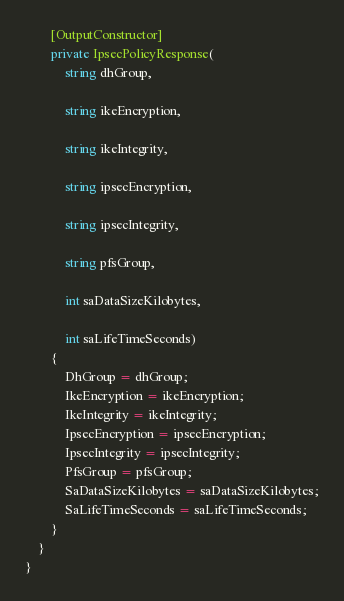Convert code to text. <code><loc_0><loc_0><loc_500><loc_500><_C#_>
        [OutputConstructor]
        private IpsecPolicyResponse(
            string dhGroup,

            string ikeEncryption,

            string ikeIntegrity,

            string ipsecEncryption,

            string ipsecIntegrity,

            string pfsGroup,

            int saDataSizeKilobytes,

            int saLifeTimeSeconds)
        {
            DhGroup = dhGroup;
            IkeEncryption = ikeEncryption;
            IkeIntegrity = ikeIntegrity;
            IpsecEncryption = ipsecEncryption;
            IpsecIntegrity = ipsecIntegrity;
            PfsGroup = pfsGroup;
            SaDataSizeKilobytes = saDataSizeKilobytes;
            SaLifeTimeSeconds = saLifeTimeSeconds;
        }
    }
}
</code> 